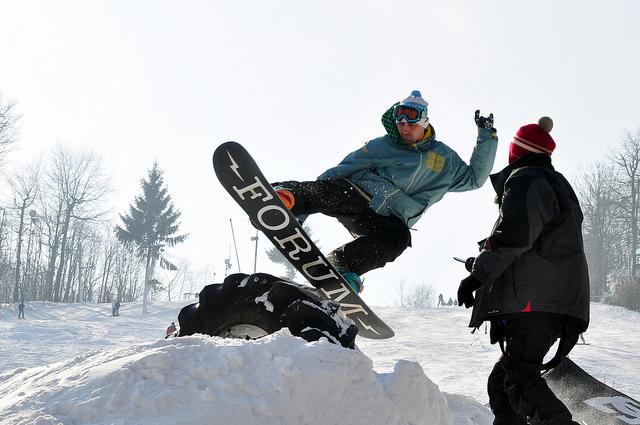What does the board say?
Answer briefly. Forum. What is the large black object?
Be succinct. Tire. Are there trees in this picture?
Answer briefly. Yes. 